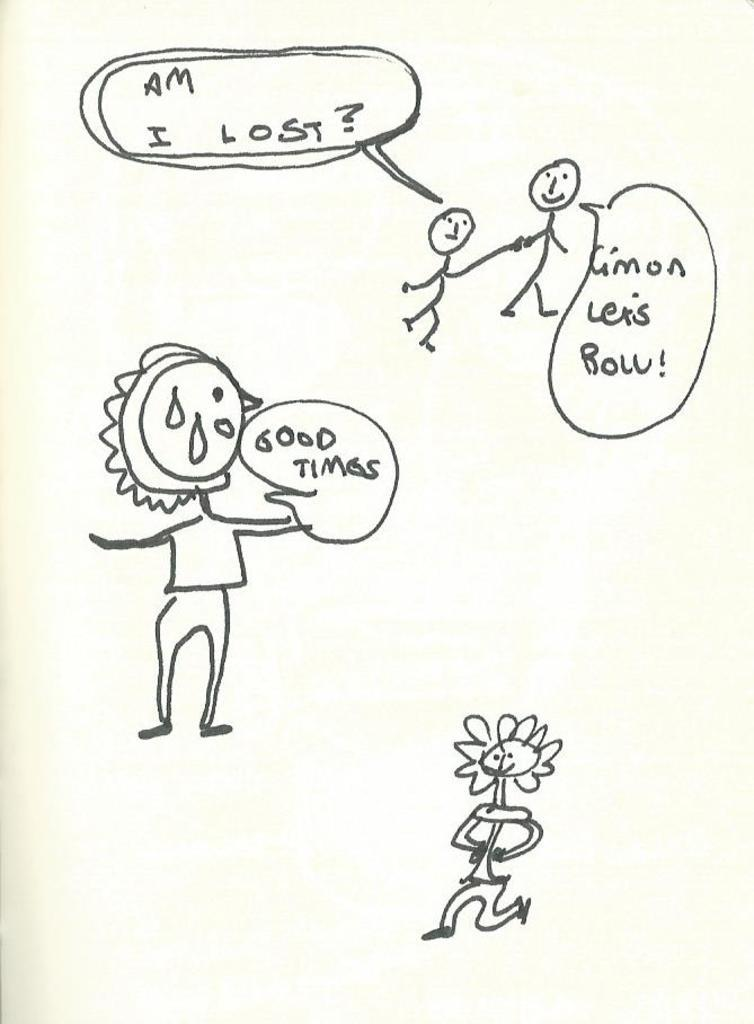What is depicted in the image? There are drawings of persons in the image. What else can be seen in the image besides the drawings of persons? There are texts in the image. What is the color of the background in the image? The background of the image is white in color. What type of cabbage can be seen growing in the image? There is no cabbage present in the image; it only contains drawings of persons and texts. 